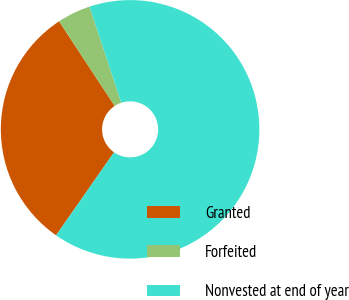<chart> <loc_0><loc_0><loc_500><loc_500><pie_chart><fcel>Granted<fcel>Forfeited<fcel>Nonvested at end of year<nl><fcel>31.04%<fcel>4.18%<fcel>64.78%<nl></chart> 